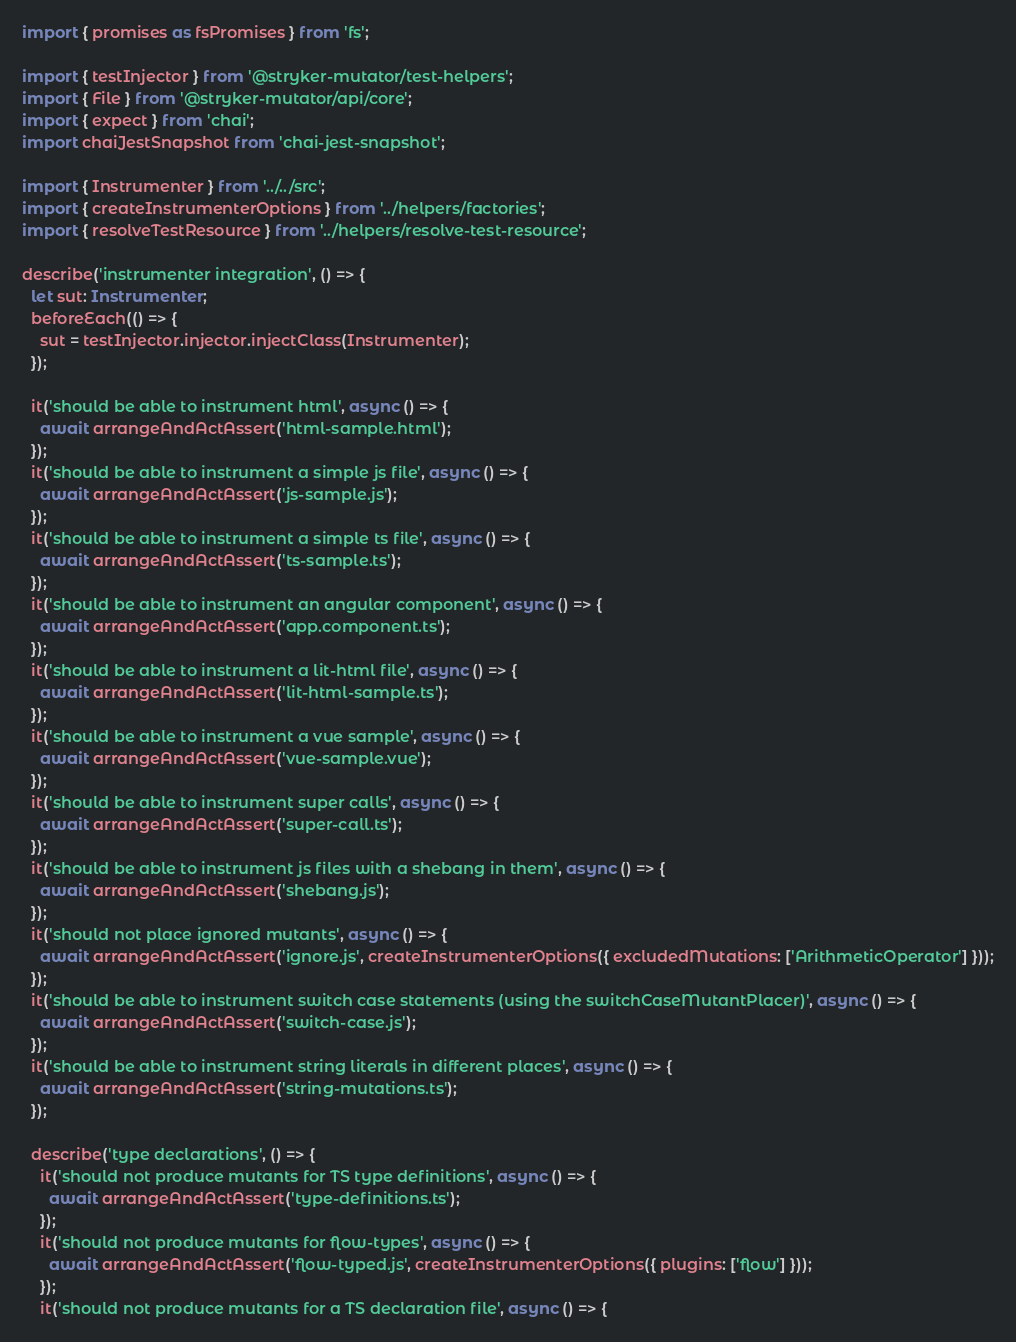Convert code to text. <code><loc_0><loc_0><loc_500><loc_500><_TypeScript_>import { promises as fsPromises } from 'fs';

import { testInjector } from '@stryker-mutator/test-helpers';
import { File } from '@stryker-mutator/api/core';
import { expect } from 'chai';
import chaiJestSnapshot from 'chai-jest-snapshot';

import { Instrumenter } from '../../src';
import { createInstrumenterOptions } from '../helpers/factories';
import { resolveTestResource } from '../helpers/resolve-test-resource';

describe('instrumenter integration', () => {
  let sut: Instrumenter;
  beforeEach(() => {
    sut = testInjector.injector.injectClass(Instrumenter);
  });

  it('should be able to instrument html', async () => {
    await arrangeAndActAssert('html-sample.html');
  });
  it('should be able to instrument a simple js file', async () => {
    await arrangeAndActAssert('js-sample.js');
  });
  it('should be able to instrument a simple ts file', async () => {
    await arrangeAndActAssert('ts-sample.ts');
  });
  it('should be able to instrument an angular component', async () => {
    await arrangeAndActAssert('app.component.ts');
  });
  it('should be able to instrument a lit-html file', async () => {
    await arrangeAndActAssert('lit-html-sample.ts');
  });
  it('should be able to instrument a vue sample', async () => {
    await arrangeAndActAssert('vue-sample.vue');
  });
  it('should be able to instrument super calls', async () => {
    await arrangeAndActAssert('super-call.ts');
  });
  it('should be able to instrument js files with a shebang in them', async () => {
    await arrangeAndActAssert('shebang.js');
  });
  it('should not place ignored mutants', async () => {
    await arrangeAndActAssert('ignore.js', createInstrumenterOptions({ excludedMutations: ['ArithmeticOperator'] }));
  });
  it('should be able to instrument switch case statements (using the switchCaseMutantPlacer)', async () => {
    await arrangeAndActAssert('switch-case.js');
  });
  it('should be able to instrument string literals in different places', async () => {
    await arrangeAndActAssert('string-mutations.ts');
  });

  describe('type declarations', () => {
    it('should not produce mutants for TS type definitions', async () => {
      await arrangeAndActAssert('type-definitions.ts');
    });
    it('should not produce mutants for flow-types', async () => {
      await arrangeAndActAssert('flow-typed.js', createInstrumenterOptions({ plugins: ['flow'] }));
    });
    it('should not produce mutants for a TS declaration file', async () => {</code> 